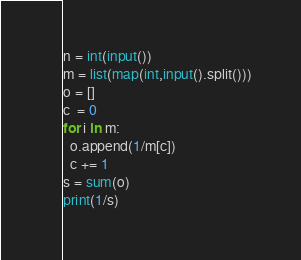Convert code to text. <code><loc_0><loc_0><loc_500><loc_500><_Python_>n = int(input())
m = list(map(int,input().split()))
o = []
c  = 0
for i in m:
  o.append(1/m[c])
  c += 1
s = sum(o)
print(1/s)</code> 